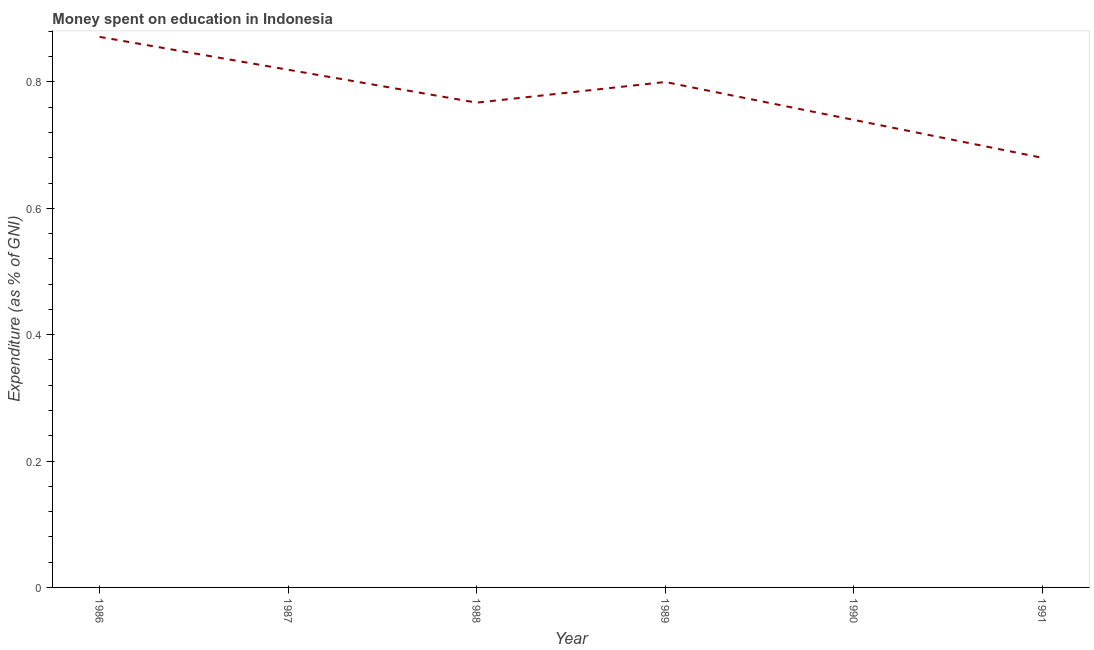Across all years, what is the maximum expenditure on education?
Offer a very short reply. 0.87. Across all years, what is the minimum expenditure on education?
Give a very brief answer. 0.68. In which year was the expenditure on education maximum?
Offer a very short reply. 1986. In which year was the expenditure on education minimum?
Offer a very short reply. 1991. What is the sum of the expenditure on education?
Your answer should be very brief. 4.68. What is the difference between the expenditure on education in 1986 and 1989?
Your response must be concise. 0.07. What is the average expenditure on education per year?
Provide a succinct answer. 0.78. What is the median expenditure on education?
Provide a succinct answer. 0.78. In how many years, is the expenditure on education greater than 0.6000000000000001 %?
Keep it short and to the point. 6. What is the ratio of the expenditure on education in 1986 to that in 1989?
Provide a short and direct response. 1.09. Is the expenditure on education in 1986 less than that in 1988?
Your answer should be compact. No. Is the difference between the expenditure on education in 1987 and 1990 greater than the difference between any two years?
Keep it short and to the point. No. What is the difference between the highest and the second highest expenditure on education?
Provide a short and direct response. 0.05. Is the sum of the expenditure on education in 1986 and 1987 greater than the maximum expenditure on education across all years?
Keep it short and to the point. Yes. What is the difference between the highest and the lowest expenditure on education?
Make the answer very short. 0.19. Does the expenditure on education monotonically increase over the years?
Provide a short and direct response. No. How many lines are there?
Offer a terse response. 1. What is the difference between two consecutive major ticks on the Y-axis?
Your answer should be very brief. 0.2. Are the values on the major ticks of Y-axis written in scientific E-notation?
Provide a succinct answer. No. Does the graph contain any zero values?
Keep it short and to the point. No. Does the graph contain grids?
Ensure brevity in your answer.  No. What is the title of the graph?
Offer a very short reply. Money spent on education in Indonesia. What is the label or title of the Y-axis?
Give a very brief answer. Expenditure (as % of GNI). What is the Expenditure (as % of GNI) of 1986?
Your response must be concise. 0.87. What is the Expenditure (as % of GNI) of 1987?
Offer a terse response. 0.82. What is the Expenditure (as % of GNI) in 1988?
Provide a succinct answer. 0.77. What is the Expenditure (as % of GNI) of 1989?
Your answer should be very brief. 0.8. What is the Expenditure (as % of GNI) in 1990?
Offer a terse response. 0.74. What is the Expenditure (as % of GNI) in 1991?
Keep it short and to the point. 0.68. What is the difference between the Expenditure (as % of GNI) in 1986 and 1987?
Offer a very short reply. 0.05. What is the difference between the Expenditure (as % of GNI) in 1986 and 1988?
Provide a short and direct response. 0.1. What is the difference between the Expenditure (as % of GNI) in 1986 and 1989?
Your response must be concise. 0.07. What is the difference between the Expenditure (as % of GNI) in 1986 and 1990?
Ensure brevity in your answer.  0.13. What is the difference between the Expenditure (as % of GNI) in 1986 and 1991?
Your answer should be compact. 0.19. What is the difference between the Expenditure (as % of GNI) in 1987 and 1988?
Your response must be concise. 0.05. What is the difference between the Expenditure (as % of GNI) in 1987 and 1989?
Your response must be concise. 0.02. What is the difference between the Expenditure (as % of GNI) in 1987 and 1990?
Offer a very short reply. 0.08. What is the difference between the Expenditure (as % of GNI) in 1987 and 1991?
Offer a very short reply. 0.14. What is the difference between the Expenditure (as % of GNI) in 1988 and 1989?
Make the answer very short. -0.03. What is the difference between the Expenditure (as % of GNI) in 1988 and 1990?
Your response must be concise. 0.03. What is the difference between the Expenditure (as % of GNI) in 1988 and 1991?
Provide a short and direct response. 0.09. What is the difference between the Expenditure (as % of GNI) in 1989 and 1991?
Provide a short and direct response. 0.12. What is the ratio of the Expenditure (as % of GNI) in 1986 to that in 1987?
Offer a very short reply. 1.06. What is the ratio of the Expenditure (as % of GNI) in 1986 to that in 1988?
Ensure brevity in your answer.  1.14. What is the ratio of the Expenditure (as % of GNI) in 1986 to that in 1989?
Offer a very short reply. 1.09. What is the ratio of the Expenditure (as % of GNI) in 1986 to that in 1990?
Your response must be concise. 1.18. What is the ratio of the Expenditure (as % of GNI) in 1986 to that in 1991?
Offer a terse response. 1.28. What is the ratio of the Expenditure (as % of GNI) in 1987 to that in 1988?
Keep it short and to the point. 1.07. What is the ratio of the Expenditure (as % of GNI) in 1987 to that in 1989?
Ensure brevity in your answer.  1.02. What is the ratio of the Expenditure (as % of GNI) in 1987 to that in 1990?
Provide a short and direct response. 1.11. What is the ratio of the Expenditure (as % of GNI) in 1987 to that in 1991?
Offer a terse response. 1.21. What is the ratio of the Expenditure (as % of GNI) in 1988 to that in 1989?
Your answer should be compact. 0.96. What is the ratio of the Expenditure (as % of GNI) in 1988 to that in 1990?
Offer a very short reply. 1.04. What is the ratio of the Expenditure (as % of GNI) in 1988 to that in 1991?
Your answer should be compact. 1.13. What is the ratio of the Expenditure (as % of GNI) in 1989 to that in 1990?
Your answer should be very brief. 1.08. What is the ratio of the Expenditure (as % of GNI) in 1989 to that in 1991?
Your response must be concise. 1.18. What is the ratio of the Expenditure (as % of GNI) in 1990 to that in 1991?
Give a very brief answer. 1.09. 